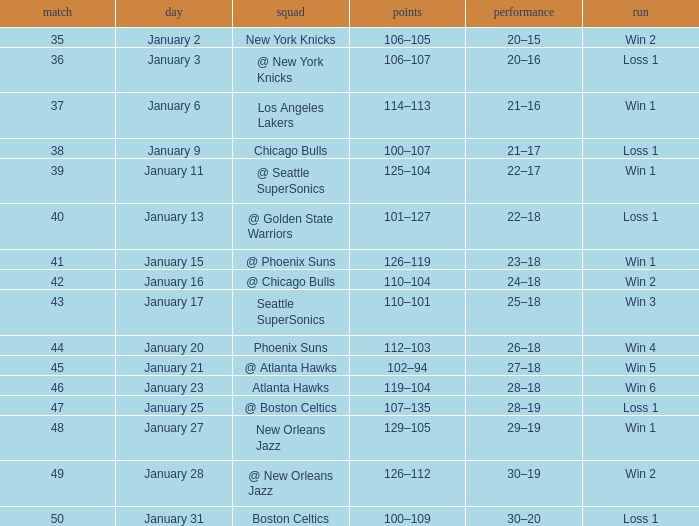What is the Team in Game 41? @ Phoenix Suns. 